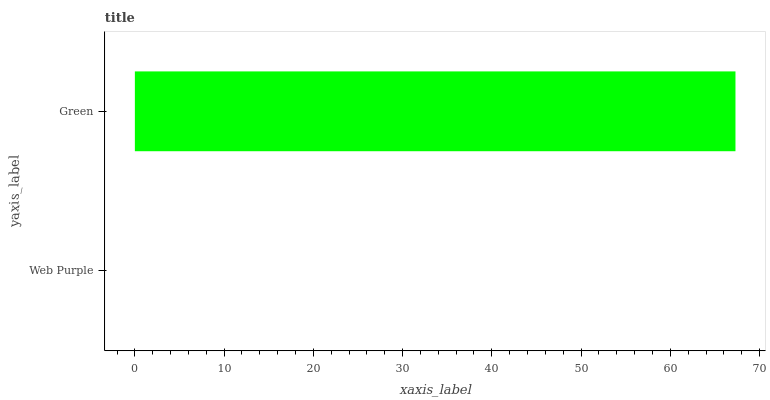Is Web Purple the minimum?
Answer yes or no. Yes. Is Green the maximum?
Answer yes or no. Yes. Is Green the minimum?
Answer yes or no. No. Is Green greater than Web Purple?
Answer yes or no. Yes. Is Web Purple less than Green?
Answer yes or no. Yes. Is Web Purple greater than Green?
Answer yes or no. No. Is Green less than Web Purple?
Answer yes or no. No. Is Green the high median?
Answer yes or no. Yes. Is Web Purple the low median?
Answer yes or no. Yes. Is Web Purple the high median?
Answer yes or no. No. Is Green the low median?
Answer yes or no. No. 